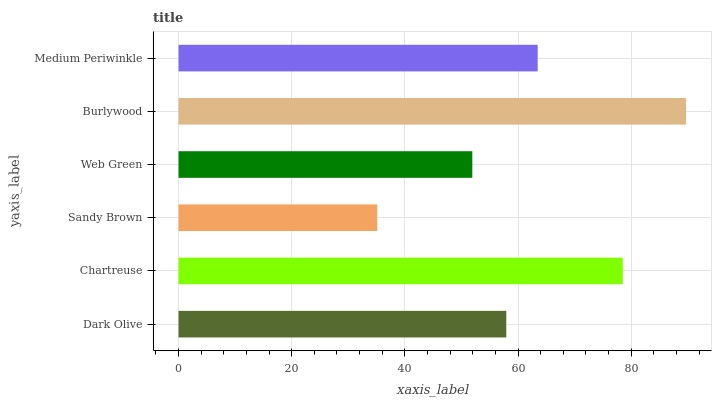Is Sandy Brown the minimum?
Answer yes or no. Yes. Is Burlywood the maximum?
Answer yes or no. Yes. Is Chartreuse the minimum?
Answer yes or no. No. Is Chartreuse the maximum?
Answer yes or no. No. Is Chartreuse greater than Dark Olive?
Answer yes or no. Yes. Is Dark Olive less than Chartreuse?
Answer yes or no. Yes. Is Dark Olive greater than Chartreuse?
Answer yes or no. No. Is Chartreuse less than Dark Olive?
Answer yes or no. No. Is Medium Periwinkle the high median?
Answer yes or no. Yes. Is Dark Olive the low median?
Answer yes or no. Yes. Is Burlywood the high median?
Answer yes or no. No. Is Medium Periwinkle the low median?
Answer yes or no. No. 